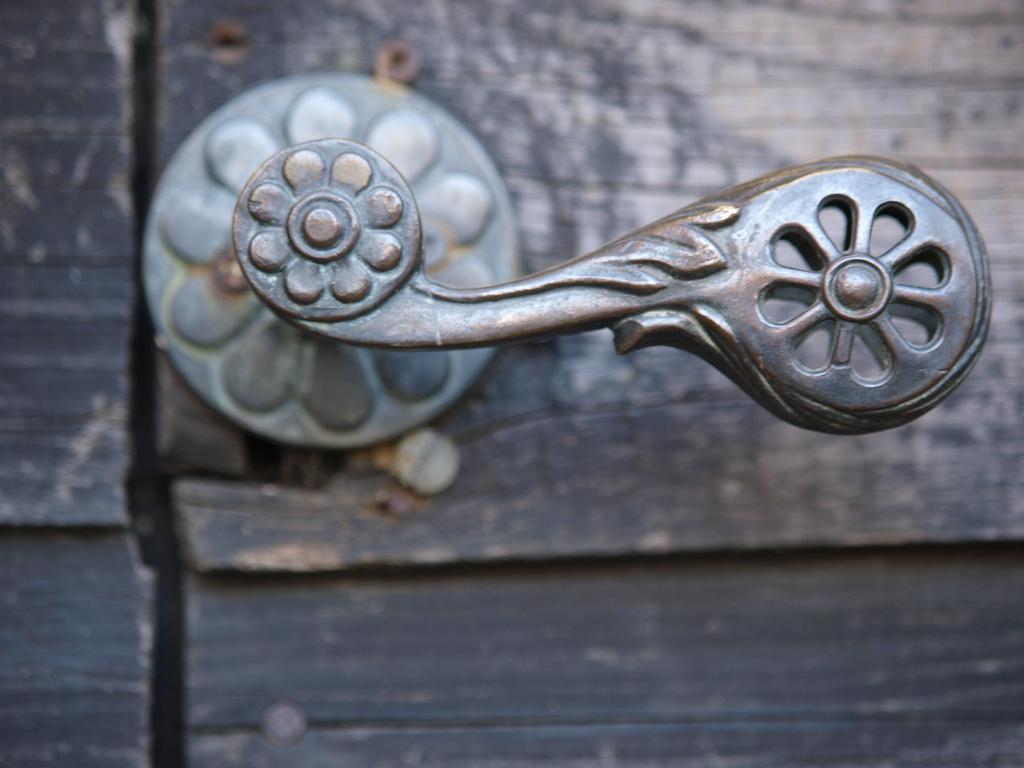In one or two sentences, can you explain what this image depicts? In this image we can see a door handle. 